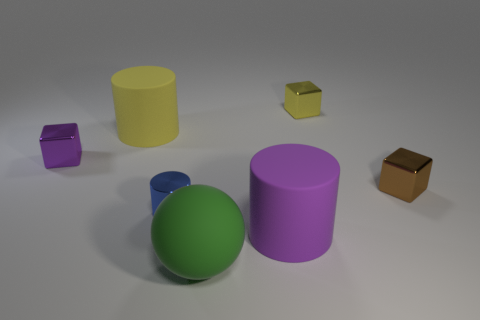Do the block that is left of the large yellow cylinder and the metal block behind the purple shiny cube have the same size?
Provide a short and direct response. Yes. How many things are either rubber things that are to the left of the green ball or big rubber things?
Give a very brief answer. 3. What material is the purple cylinder?
Your response must be concise. Rubber. Is the green rubber ball the same size as the purple cylinder?
Offer a terse response. Yes. What number of blocks are yellow matte things or blue shiny objects?
Offer a very short reply. 0. The large rubber cylinder that is behind the brown block behind the tiny cylinder is what color?
Offer a terse response. Yellow. Are there fewer yellow shiny things in front of the big green matte ball than small shiny cubes that are on the right side of the purple cylinder?
Offer a very short reply. Yes. Is the size of the yellow rubber cylinder the same as the purple object left of the blue metal cylinder?
Your answer should be very brief. No. What is the shape of the large matte object that is on the left side of the large purple thing and in front of the tiny shiny cylinder?
Keep it short and to the point. Sphere. What size is the green thing that is made of the same material as the large purple thing?
Offer a very short reply. Large. 